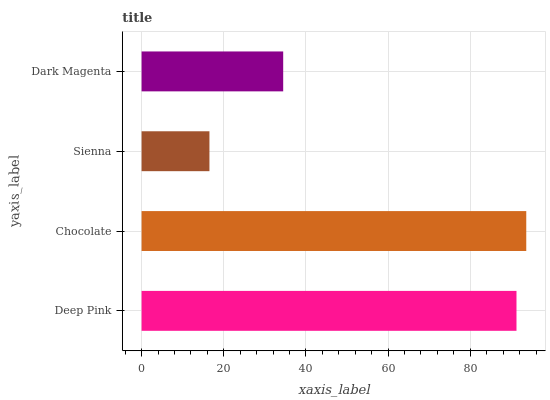Is Sienna the minimum?
Answer yes or no. Yes. Is Chocolate the maximum?
Answer yes or no. Yes. Is Chocolate the minimum?
Answer yes or no. No. Is Sienna the maximum?
Answer yes or no. No. Is Chocolate greater than Sienna?
Answer yes or no. Yes. Is Sienna less than Chocolate?
Answer yes or no. Yes. Is Sienna greater than Chocolate?
Answer yes or no. No. Is Chocolate less than Sienna?
Answer yes or no. No. Is Deep Pink the high median?
Answer yes or no. Yes. Is Dark Magenta the low median?
Answer yes or no. Yes. Is Sienna the high median?
Answer yes or no. No. Is Deep Pink the low median?
Answer yes or no. No. 